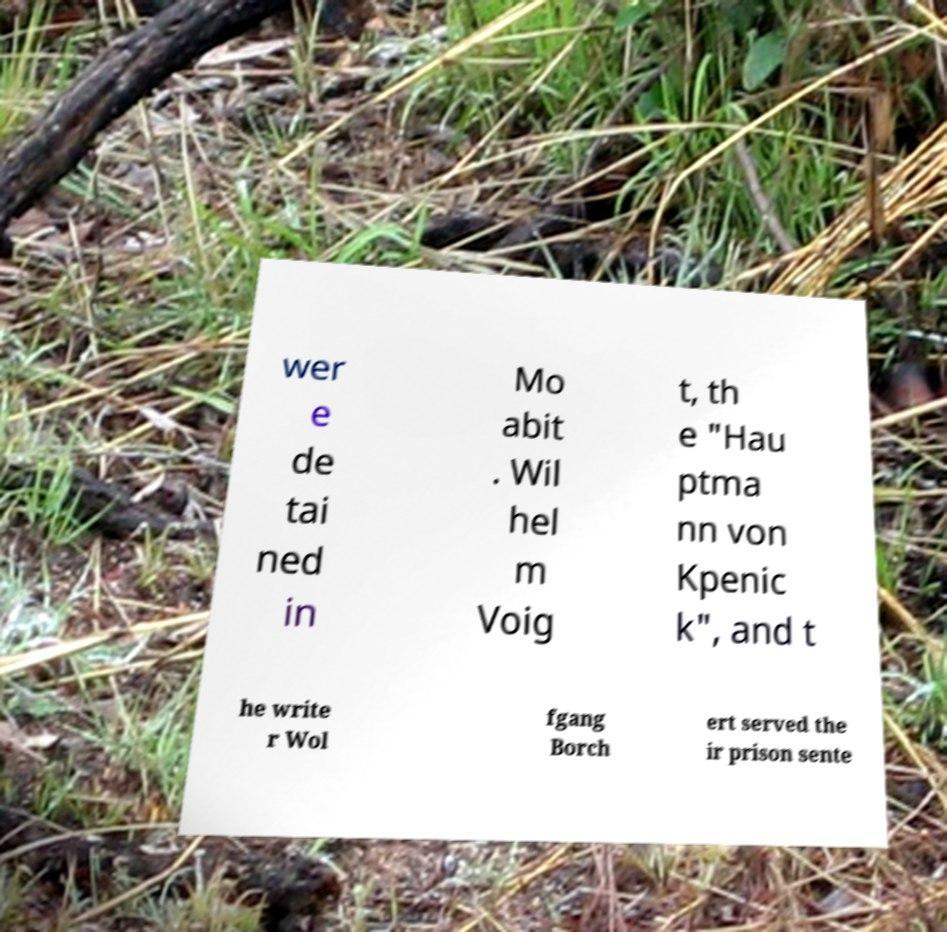Could you extract and type out the text from this image? wer e de tai ned in Mo abit . Wil hel m Voig t, th e "Hau ptma nn von Kpenic k", and t he write r Wol fgang Borch ert served the ir prison sente 